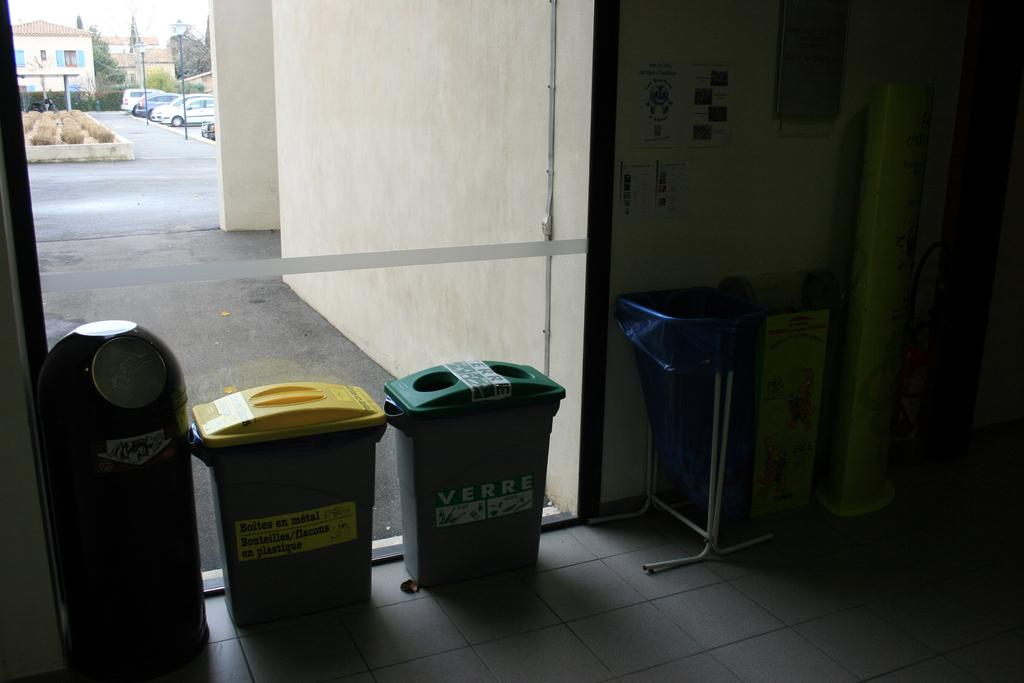<image>
Create a compact narrative representing the image presented. A glass wall with a trashcan and recycling bins lined up against it. 